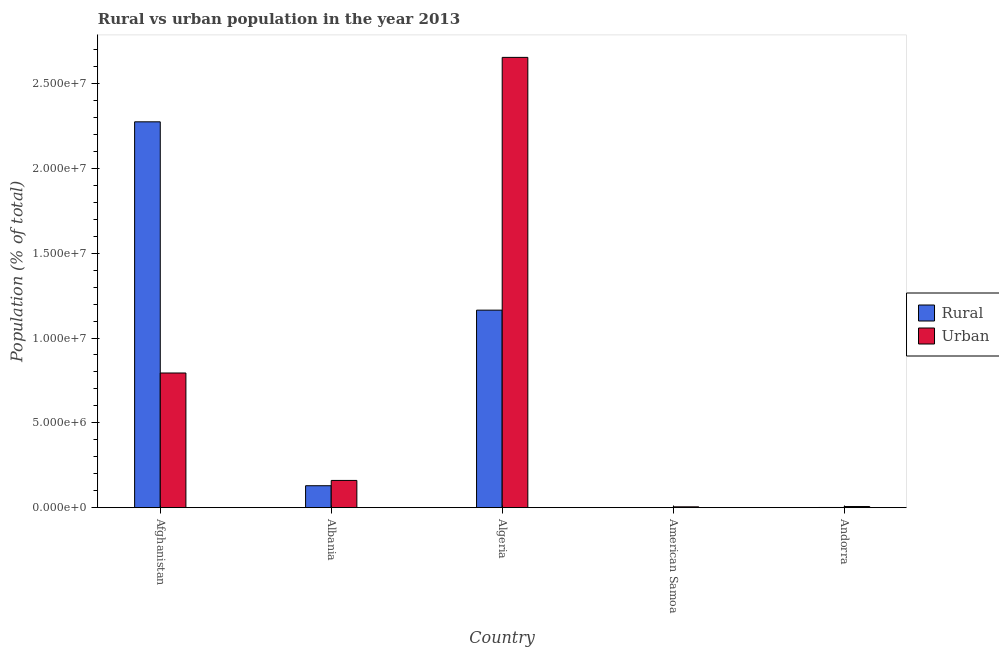Are the number of bars per tick equal to the number of legend labels?
Ensure brevity in your answer.  Yes. Are the number of bars on each tick of the X-axis equal?
Offer a terse response. Yes. What is the label of the 4th group of bars from the left?
Give a very brief answer. American Samoa. In how many cases, is the number of bars for a given country not equal to the number of legend labels?
Provide a short and direct response. 0. What is the urban population density in American Samoa?
Provide a short and direct response. 4.83e+04. Across all countries, what is the maximum rural population density?
Provide a short and direct response. 2.27e+07. Across all countries, what is the minimum urban population density?
Provide a succinct answer. 4.83e+04. In which country was the rural population density maximum?
Keep it short and to the point. Afghanistan. In which country was the urban population density minimum?
Provide a succinct answer. American Samoa. What is the total urban population density in the graph?
Provide a succinct answer. 3.62e+07. What is the difference between the rural population density in American Samoa and that in Andorra?
Provide a succinct answer. -3496. What is the difference between the rural population density in Afghanistan and the urban population density in Albania?
Your answer should be very brief. 2.11e+07. What is the average urban population density per country?
Your response must be concise. 7.24e+06. What is the difference between the rural population density and urban population density in Afghanistan?
Offer a very short reply. 1.48e+07. What is the ratio of the urban population density in Afghanistan to that in American Samoa?
Provide a short and direct response. 164.36. Is the difference between the urban population density in Algeria and American Samoa greater than the difference between the rural population density in Algeria and American Samoa?
Give a very brief answer. Yes. What is the difference between the highest and the second highest urban population density?
Your answer should be very brief. 1.86e+07. What is the difference between the highest and the lowest rural population density?
Give a very brief answer. 2.27e+07. Is the sum of the rural population density in American Samoa and Andorra greater than the maximum urban population density across all countries?
Offer a terse response. No. What does the 1st bar from the left in American Samoa represents?
Your response must be concise. Rural. What does the 2nd bar from the right in Algeria represents?
Keep it short and to the point. Rural. How many countries are there in the graph?
Your answer should be compact. 5. Does the graph contain any zero values?
Your answer should be compact. No. Does the graph contain grids?
Your answer should be compact. No. How many legend labels are there?
Provide a short and direct response. 2. What is the title of the graph?
Give a very brief answer. Rural vs urban population in the year 2013. Does "Birth rate" appear as one of the legend labels in the graph?
Keep it short and to the point. No. What is the label or title of the X-axis?
Your answer should be compact. Country. What is the label or title of the Y-axis?
Your answer should be compact. Population (% of total). What is the Population (% of total) in Rural in Afghanistan?
Provide a short and direct response. 2.27e+07. What is the Population (% of total) in Urban in Afghanistan?
Provide a short and direct response. 7.94e+06. What is the Population (% of total) in Rural in Albania?
Provide a short and direct response. 1.29e+06. What is the Population (% of total) in Urban in Albania?
Provide a succinct answer. 1.60e+06. What is the Population (% of total) of Rural in Algeria?
Provide a short and direct response. 1.16e+07. What is the Population (% of total) of Urban in Algeria?
Give a very brief answer. 2.65e+07. What is the Population (% of total) in Rural in American Samoa?
Offer a terse response. 7005. What is the Population (% of total) of Urban in American Samoa?
Make the answer very short. 4.83e+04. What is the Population (% of total) of Rural in Andorra?
Your response must be concise. 1.05e+04. What is the Population (% of total) of Urban in Andorra?
Provide a succinct answer. 6.54e+04. Across all countries, what is the maximum Population (% of total) of Rural?
Keep it short and to the point. 2.27e+07. Across all countries, what is the maximum Population (% of total) in Urban?
Your response must be concise. 2.65e+07. Across all countries, what is the minimum Population (% of total) of Rural?
Give a very brief answer. 7005. Across all countries, what is the minimum Population (% of total) in Urban?
Provide a short and direct response. 4.83e+04. What is the total Population (% of total) of Rural in the graph?
Provide a short and direct response. 3.57e+07. What is the total Population (% of total) of Urban in the graph?
Your response must be concise. 3.62e+07. What is the difference between the Population (% of total) of Rural in Afghanistan and that in Albania?
Your answer should be compact. 2.15e+07. What is the difference between the Population (% of total) in Urban in Afghanistan and that in Albania?
Give a very brief answer. 6.33e+06. What is the difference between the Population (% of total) of Rural in Afghanistan and that in Algeria?
Your response must be concise. 1.11e+07. What is the difference between the Population (% of total) in Urban in Afghanistan and that in Algeria?
Your answer should be compact. -1.86e+07. What is the difference between the Population (% of total) of Rural in Afghanistan and that in American Samoa?
Give a very brief answer. 2.27e+07. What is the difference between the Population (% of total) in Urban in Afghanistan and that in American Samoa?
Offer a very short reply. 7.89e+06. What is the difference between the Population (% of total) in Rural in Afghanistan and that in Andorra?
Make the answer very short. 2.27e+07. What is the difference between the Population (% of total) in Urban in Afghanistan and that in Andorra?
Ensure brevity in your answer.  7.87e+06. What is the difference between the Population (% of total) in Rural in Albania and that in Algeria?
Offer a very short reply. -1.04e+07. What is the difference between the Population (% of total) in Urban in Albania and that in Algeria?
Your answer should be very brief. -2.49e+07. What is the difference between the Population (% of total) of Rural in Albania and that in American Samoa?
Give a very brief answer. 1.29e+06. What is the difference between the Population (% of total) of Urban in Albania and that in American Samoa?
Ensure brevity in your answer.  1.56e+06. What is the difference between the Population (% of total) in Rural in Albania and that in Andorra?
Offer a very short reply. 1.28e+06. What is the difference between the Population (% of total) of Urban in Albania and that in Andorra?
Offer a very short reply. 1.54e+06. What is the difference between the Population (% of total) in Rural in Algeria and that in American Samoa?
Offer a very short reply. 1.16e+07. What is the difference between the Population (% of total) in Urban in Algeria and that in American Samoa?
Your answer should be very brief. 2.65e+07. What is the difference between the Population (% of total) in Rural in Algeria and that in Andorra?
Offer a terse response. 1.16e+07. What is the difference between the Population (% of total) in Urban in Algeria and that in Andorra?
Offer a very short reply. 2.65e+07. What is the difference between the Population (% of total) in Rural in American Samoa and that in Andorra?
Offer a terse response. -3496. What is the difference between the Population (% of total) of Urban in American Samoa and that in Andorra?
Make the answer very short. -1.71e+04. What is the difference between the Population (% of total) in Rural in Afghanistan and the Population (% of total) in Urban in Albania?
Offer a very short reply. 2.11e+07. What is the difference between the Population (% of total) of Rural in Afghanistan and the Population (% of total) of Urban in Algeria?
Make the answer very short. -3.80e+06. What is the difference between the Population (% of total) in Rural in Afghanistan and the Population (% of total) in Urban in American Samoa?
Offer a terse response. 2.27e+07. What is the difference between the Population (% of total) of Rural in Afghanistan and the Population (% of total) of Urban in Andorra?
Your answer should be very brief. 2.27e+07. What is the difference between the Population (% of total) in Rural in Albania and the Population (% of total) in Urban in Algeria?
Your answer should be compact. -2.53e+07. What is the difference between the Population (% of total) in Rural in Albania and the Population (% of total) in Urban in American Samoa?
Offer a terse response. 1.24e+06. What is the difference between the Population (% of total) in Rural in Albania and the Population (% of total) in Urban in Andorra?
Offer a terse response. 1.23e+06. What is the difference between the Population (% of total) in Rural in Algeria and the Population (% of total) in Urban in American Samoa?
Offer a terse response. 1.16e+07. What is the difference between the Population (% of total) in Rural in Algeria and the Population (% of total) in Urban in Andorra?
Provide a short and direct response. 1.16e+07. What is the difference between the Population (% of total) of Rural in American Samoa and the Population (% of total) of Urban in Andorra?
Your answer should be compact. -5.84e+04. What is the average Population (% of total) in Rural per country?
Provide a short and direct response. 7.14e+06. What is the average Population (% of total) in Urban per country?
Your answer should be compact. 7.24e+06. What is the difference between the Population (% of total) of Rural and Population (% of total) of Urban in Afghanistan?
Make the answer very short. 1.48e+07. What is the difference between the Population (% of total) in Rural and Population (% of total) in Urban in Albania?
Keep it short and to the point. -3.12e+05. What is the difference between the Population (% of total) of Rural and Population (% of total) of Urban in Algeria?
Your response must be concise. -1.49e+07. What is the difference between the Population (% of total) in Rural and Population (% of total) in Urban in American Samoa?
Offer a terse response. -4.13e+04. What is the difference between the Population (% of total) in Rural and Population (% of total) in Urban in Andorra?
Offer a terse response. -5.49e+04. What is the ratio of the Population (% of total) in Rural in Afghanistan to that in Albania?
Offer a very short reply. 17.59. What is the ratio of the Population (% of total) in Urban in Afghanistan to that in Albania?
Provide a short and direct response. 4.95. What is the ratio of the Population (% of total) in Rural in Afghanistan to that in Algeria?
Provide a short and direct response. 1.95. What is the ratio of the Population (% of total) of Urban in Afghanistan to that in Algeria?
Provide a succinct answer. 0.3. What is the ratio of the Population (% of total) in Rural in Afghanistan to that in American Samoa?
Provide a succinct answer. 3246.91. What is the ratio of the Population (% of total) in Urban in Afghanistan to that in American Samoa?
Your response must be concise. 164.36. What is the ratio of the Population (% of total) in Rural in Afghanistan to that in Andorra?
Your answer should be compact. 2165.95. What is the ratio of the Population (% of total) in Urban in Afghanistan to that in Andorra?
Offer a terse response. 121.37. What is the ratio of the Population (% of total) in Rural in Albania to that in Algeria?
Offer a very short reply. 0.11. What is the ratio of the Population (% of total) in Urban in Albania to that in Algeria?
Give a very brief answer. 0.06. What is the ratio of the Population (% of total) of Rural in Albania to that in American Samoa?
Offer a very short reply. 184.54. What is the ratio of the Population (% of total) of Urban in Albania to that in American Samoa?
Offer a terse response. 33.22. What is the ratio of the Population (% of total) of Rural in Albania to that in Andorra?
Provide a succinct answer. 123.1. What is the ratio of the Population (% of total) in Urban in Albania to that in Andorra?
Your answer should be compact. 24.54. What is the ratio of the Population (% of total) of Rural in Algeria to that in American Samoa?
Offer a terse response. 1662.09. What is the ratio of the Population (% of total) of Urban in Algeria to that in American Samoa?
Offer a very short reply. 549.58. What is the ratio of the Population (% of total) of Rural in Algeria to that in Andorra?
Your answer should be very brief. 1108.75. What is the ratio of the Population (% of total) in Urban in Algeria to that in Andorra?
Offer a very short reply. 405.85. What is the ratio of the Population (% of total) of Rural in American Samoa to that in Andorra?
Provide a short and direct response. 0.67. What is the ratio of the Population (% of total) in Urban in American Samoa to that in Andorra?
Your response must be concise. 0.74. What is the difference between the highest and the second highest Population (% of total) in Rural?
Provide a succinct answer. 1.11e+07. What is the difference between the highest and the second highest Population (% of total) in Urban?
Offer a terse response. 1.86e+07. What is the difference between the highest and the lowest Population (% of total) of Rural?
Your answer should be very brief. 2.27e+07. What is the difference between the highest and the lowest Population (% of total) in Urban?
Your answer should be compact. 2.65e+07. 